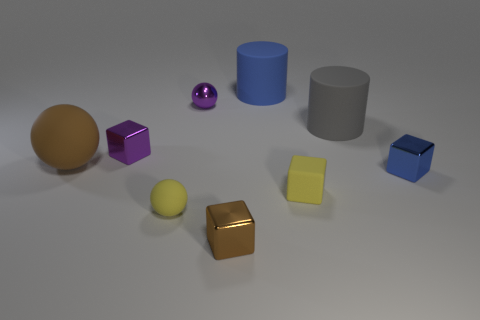Is the color of the tiny matte block the same as the small rubber ball?
Keep it short and to the point. Yes. Is the number of rubber cylinders less than the number of brown metallic things?
Offer a terse response. No. Does the tiny purple thing that is to the left of the yellow rubber ball have the same material as the blue thing to the right of the large blue rubber cylinder?
Offer a very short reply. Yes. Is the number of big balls that are left of the brown matte sphere less than the number of tiny green shiny objects?
Provide a short and direct response. No. There is a tiny sphere that is to the left of the purple ball; how many small yellow cubes are in front of it?
Ensure brevity in your answer.  0. What is the size of the shiny cube that is both left of the big gray thing and behind the brown shiny block?
Your answer should be compact. Small. Do the tiny brown cube and the blue object that is right of the blue cylinder have the same material?
Your answer should be compact. Yes. Is the number of purple metal things to the right of the tiny blue metal cube less than the number of big brown matte spheres behind the tiny yellow cube?
Make the answer very short. Yes. What is the big blue cylinder behind the small rubber cube made of?
Provide a succinct answer. Rubber. What color is the matte thing that is on the right side of the big brown rubber ball and to the left of the tiny brown thing?
Give a very brief answer. Yellow. 